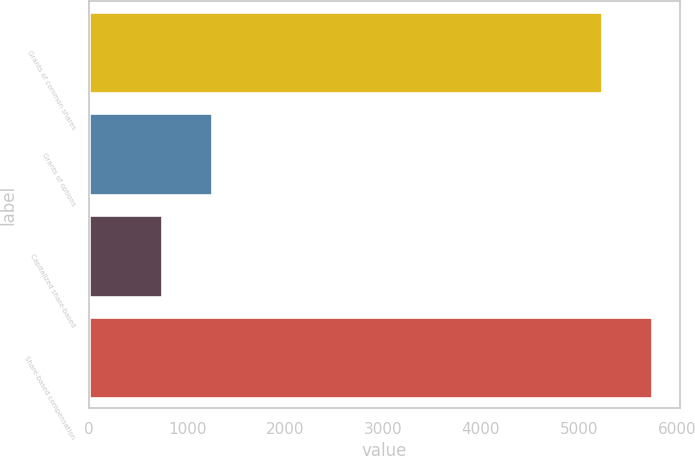Convert chart. <chart><loc_0><loc_0><loc_500><loc_500><bar_chart><fcel>Grants of common shares<fcel>Grants of options<fcel>Capitalized share-based<fcel>Share-based compensation<nl><fcel>5232<fcel>1255<fcel>745<fcel>5742<nl></chart> 